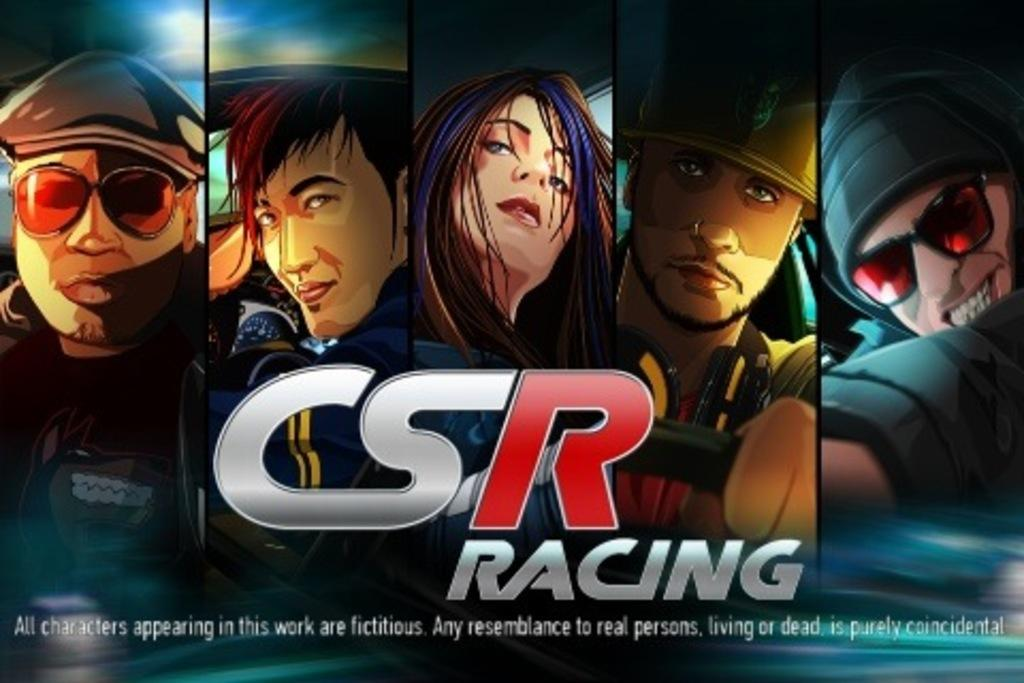What type of characters are present in the image? There are cartoon characters in the image. How are the cartoon characters arranged in the image? The cartoon characters are arranged from left to right. What type of jewel is being held by the cartoon character on the right side of the image? There is no jewel present in the image; it only features cartoon characters arranged from left to right. 